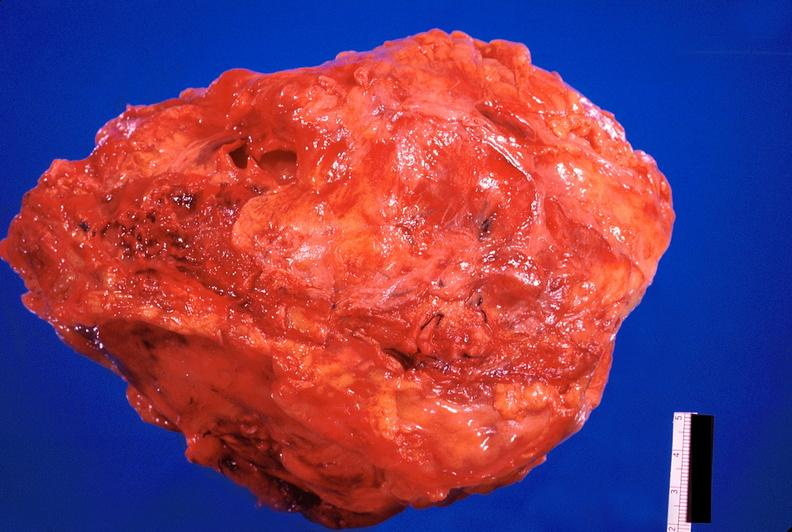does this image show pericarditis, secondary to mediastanitis from pseudomonas and enterobacter 14 days post op?
Answer the question using a single word or phrase. Yes 